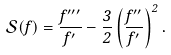<formula> <loc_0><loc_0><loc_500><loc_500>\mathcal { S } ( f ) = \frac { f ^ { \prime \prime \prime } } { f ^ { \prime } } - \frac { 3 } { 2 } \left ( \frac { f ^ { \prime \prime } } { f ^ { \prime } } \right ) ^ { 2 } .</formula> 